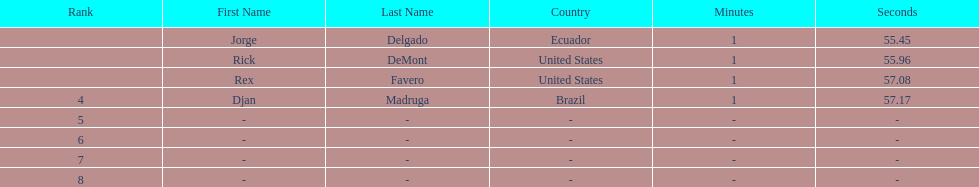How many ranked swimmers were from the united states? 2. 